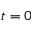Convert formula to latex. <formula><loc_0><loc_0><loc_500><loc_500>t = 0</formula> 